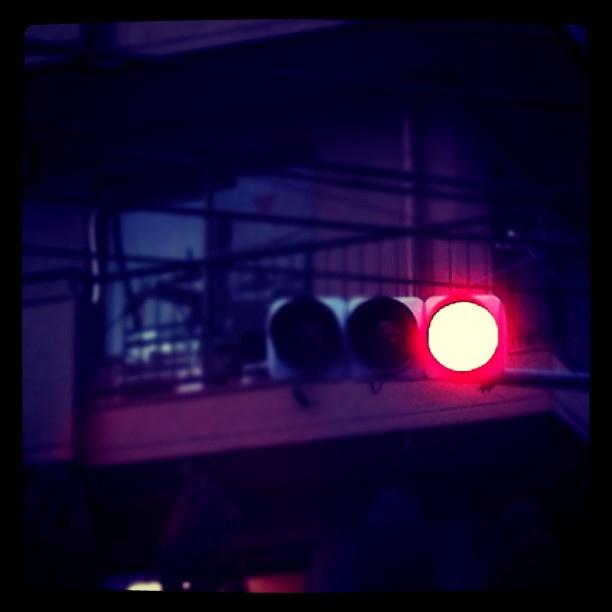Are all of the lights turned on?
Quick response, please. No. What type of light is this?
Answer briefly. Traffic light. Is this a phone?
Keep it brief. No. How many light sockets are there?
Give a very brief answer. 3. Is this special effects?
Concise answer only. No. How many lights are on?
Concise answer only. 1. 